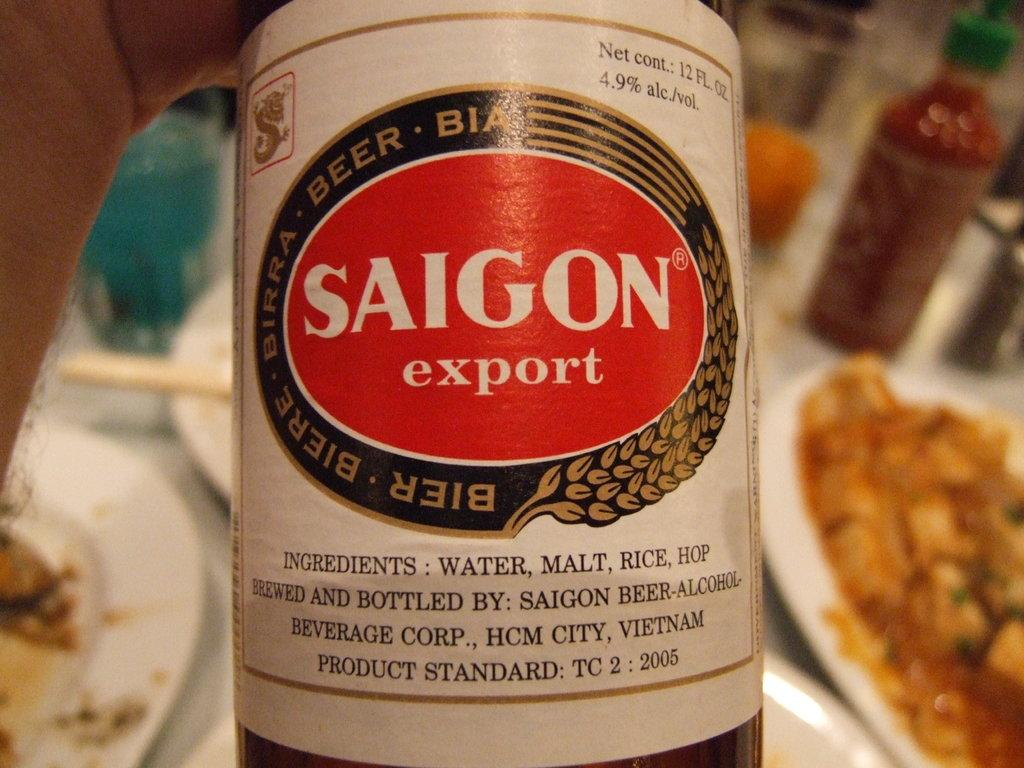<image>
Give a short and clear explanation of the subsequent image. A bottle of Saigon Export malt beer with the Saigon logo in red, white, black and gold colors. 